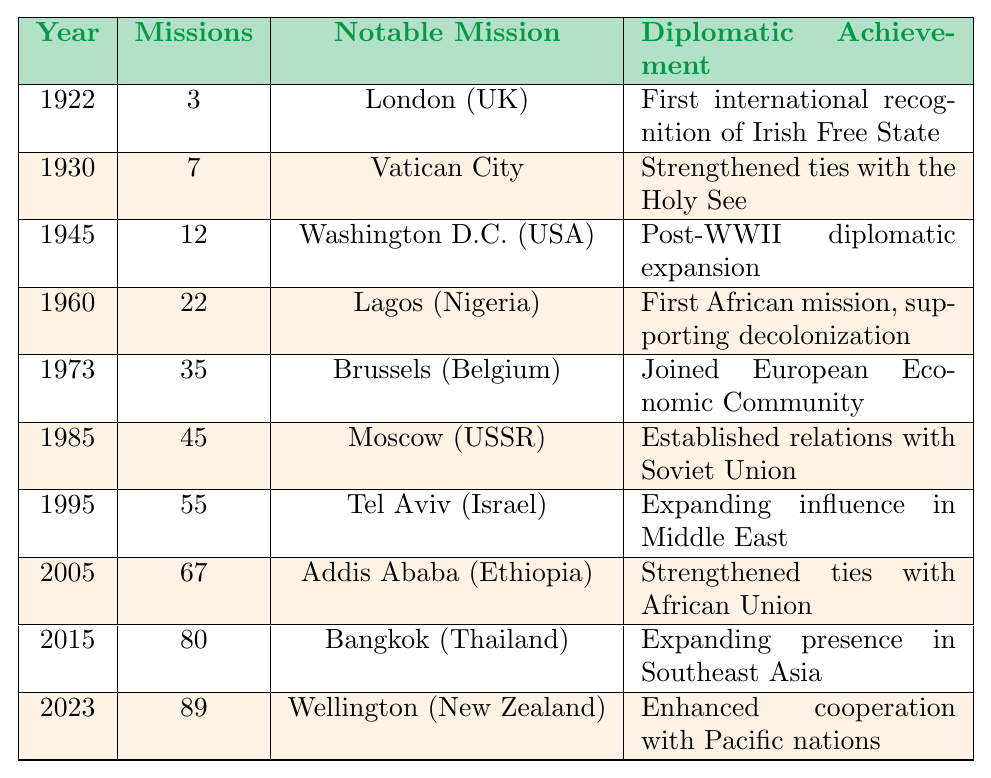What year did Ireland establish its first diplomatic mission? According to the table, the first diplomatic mission was established in 1922.
Answer: 1922 How many diplomatic missions were there in 1985? The table shows that in 1985, there were 45 diplomatic missions.
Answer: 45 What was the notable mission established in 2005? The table indicates that in 2005, the notable mission was in Addis Ababa, Ethiopia.
Answer: Addis Ababa (Ethiopia) Which year had the highest number of diplomatic missions? By examining the table, it can be seen that in 2023, there were 89 diplomatic missions, which is the highest.
Answer: 2023 What achievement was associated with the establishment of the mission in London in 1922? The table states that the achievement was the first international recognition of the Irish Free State.
Answer: First international recognition of Irish Free State How many more missions were established from 1922 to 1960 than from 1985 to 2023? From 1922 to 1960, the total number of missions was 3 (1922) + 7 (1930) + 12 (1945) + 22 (1960) = 44. From 1985 to 2023, it was 45 (1985) + 67 (2005) + 80 (2015) + 89 (2023) = 281. The difference is 281 - 44 = 237.
Answer: 237 Is it true that Dublin has been recognized for establishing a mission in the Pacific region? The table lists Wellington, New Zealand, as the notable mission in 2023, which indicates a presence in the Pacific, hence the statement is true.
Answer: True How many missions were established between 1973 and 1985? The number of missions increased from 35 in 1973 to 45 in 1985. The difference is 45 - 35 = 10 missions established during that period.
Answer: 10 What was the trend in the number of missions from 1945 to 2023? The table shows an increasing trend from 12 missions in 1945 to 89 in 2023, indicating a strong and steady growth.
Answer: Steady growth What was the significance of the mission established in Brussels in 1973? The table notes that the significance of this mission was joining the European Economic Community, which was a landmark event for Ireland.
Answer: Joined European Economic Community In which year did Ireland strengthen ties with the Holy See, and how many missions were there that year? The year was 1930, and there were 7 missions established that year.
Answer: 1930, 7 missions 